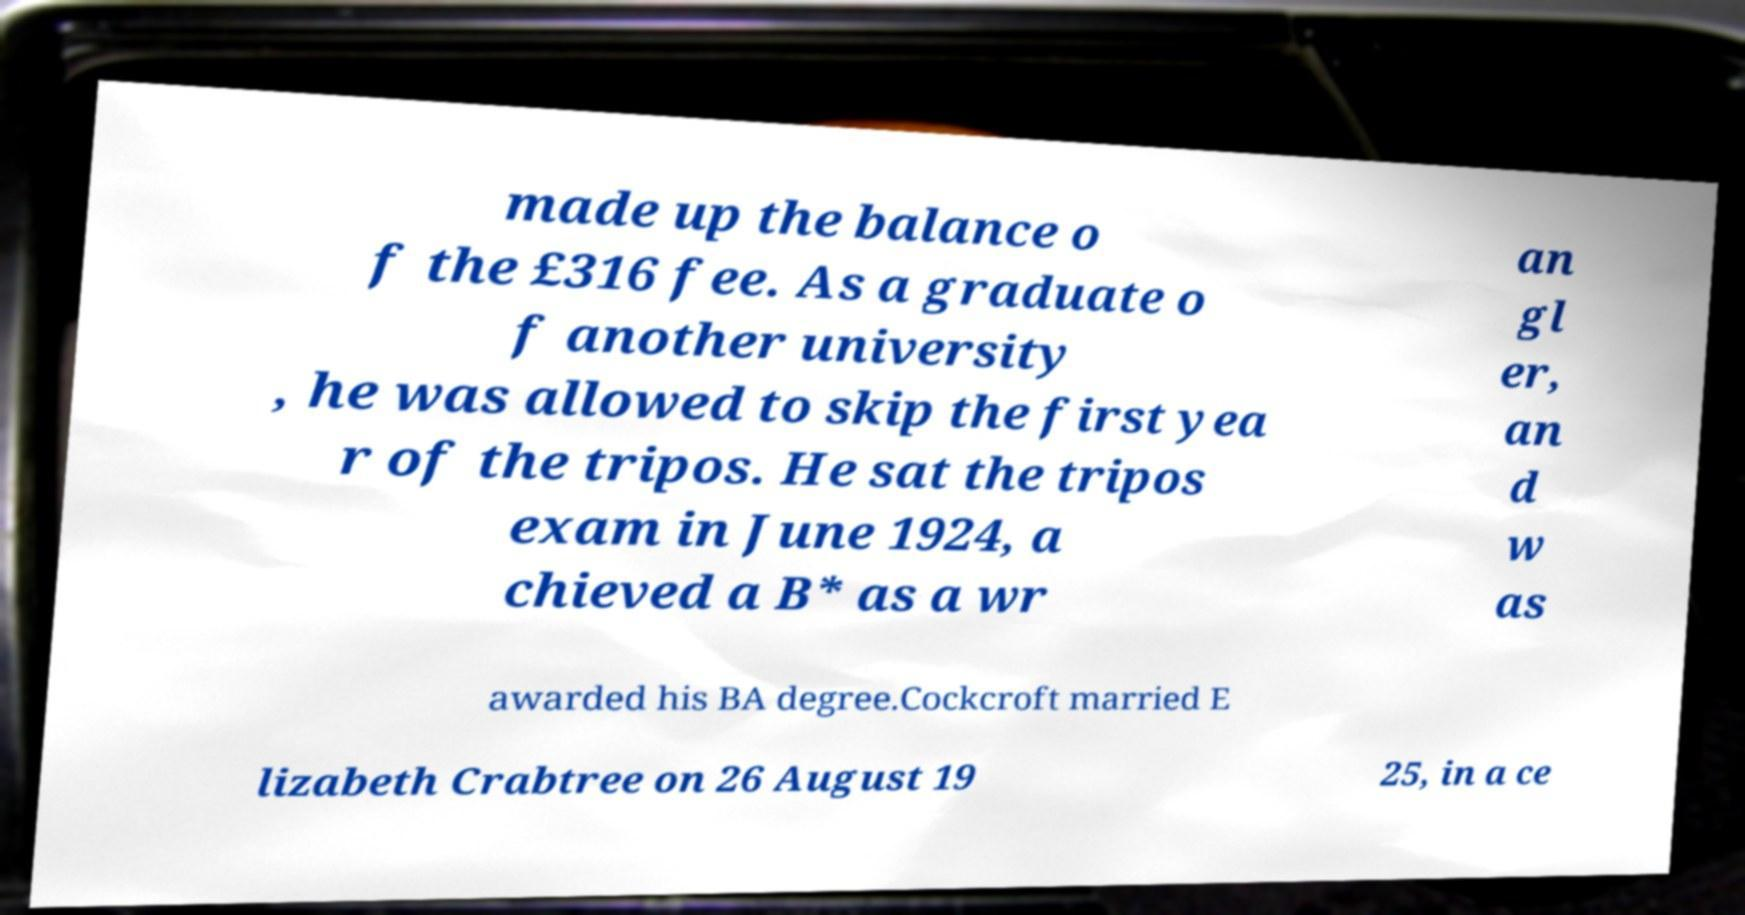Could you extract and type out the text from this image? made up the balance o f the £316 fee. As a graduate o f another university , he was allowed to skip the first yea r of the tripos. He sat the tripos exam in June 1924, a chieved a B* as a wr an gl er, an d w as awarded his BA degree.Cockcroft married E lizabeth Crabtree on 26 August 19 25, in a ce 